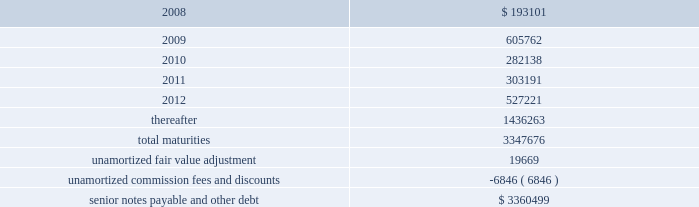Ventas , inc .
Notes to consolidated financial statements 2014 ( continued ) applicable indenture .
The issuers may also redeem the 2015 senior notes , in whole at any time or in part from time to time , on or after june 1 , 2010 at varying redemption prices set forth in the applicable indenture , plus accrued and unpaid interest thereon to the redemption date .
In addition , at any time prior to june 1 , 2008 , the issuers may redeem up to 35% ( 35 % ) of the aggregate principal amount of either or both of the 2010 senior notes and 2015 senior notes with the net cash proceeds from certain equity offerings at redemption prices equal to 106.750% ( 106.750 % ) and 107.125% ( 107.125 % ) , respectively , of the principal amount thereof , plus , in each case , accrued and unpaid interest thereon to the redemption date .
The issuers may redeem the 2014 senior notes , in whole at any time or in part from time to time , ( i ) prior to october 15 , 2009 at a redemption price equal to 100% ( 100 % ) of the principal amount thereof , plus a make-whole premium as described in the applicable indenture and ( ii ) on or after october 15 , 2009 at varying redemption prices set forth in the applicable indenture , plus , in each case , accrued and unpaid interest thereon to the redemption date .
The issuers may redeem the 2009 senior notes and the 2012 senior notes , in whole at any time or in part from time to time , at a redemption price equal to 100% ( 100 % ) of the principal amount thereof , plus accrued and unpaid interest thereon to the redemption date and a make-whole premium as described in the applicable indenture .
If we experience certain kinds of changes of control , the issuers must make an offer to repurchase the senior notes , in whole or in part , at a purchase price in cash equal to 101% ( 101 % ) of the principal amount of the senior notes , plus any accrued and unpaid interest to the date of purchase ; provided , however , that in the event moody 2019s and s&p have confirmed their ratings at ba3 or higher and bb- or higher on the senior notes and certain other conditions are met , this repurchase obligation will not apply .
Mortgages at december 31 , 2007 , we had outstanding 121 mortgage loans totaling $ 1.57 billion that are collateralized by the underlying assets of the properties .
Outstanding principal balances on these loans ranged from $ 0.4 million to $ 59.4 million as of december 31 , 2007 .
The loans generally bear interest at fixed rates ranging from 5.4% ( 5.4 % ) to 8.5% ( 8.5 % ) per annum , except for 15 loans with outstanding principal balances ranging from $ 0.4 million to $ 32.0 million , which bear interest at the lender 2019s variable rates ranging from 3.4% ( 3.4 % ) to 7.3% ( 7.3 % ) per annum as of december 31 , 2007 .
At december 31 , 2007 , the weighted average annual rate on fixed rate debt was 6.5% ( 6.5 % ) and the weighted average annual rate on the variable rate debt was 6.1% ( 6.1 % ) .
The loans had a weighted average maturity of 7.0 years as of december 31 , 2007 .
Sunrise 2019s portion of total debt was $ 157.1 million as of december 31 , scheduled maturities of borrowing arrangements and other provisions as of december 31 , 2007 , our indebtedness had the following maturities ( in thousands ) : .

What was the growth rate of maturities from 2008 to 2009? 
Rationale: the percentage change in the maturities from 2008 to 2009 is the rate of the growth of the maturities from that year to th enxt
Computations: ((605762 - 193101) / 193101)
Answer: 2.13702. 